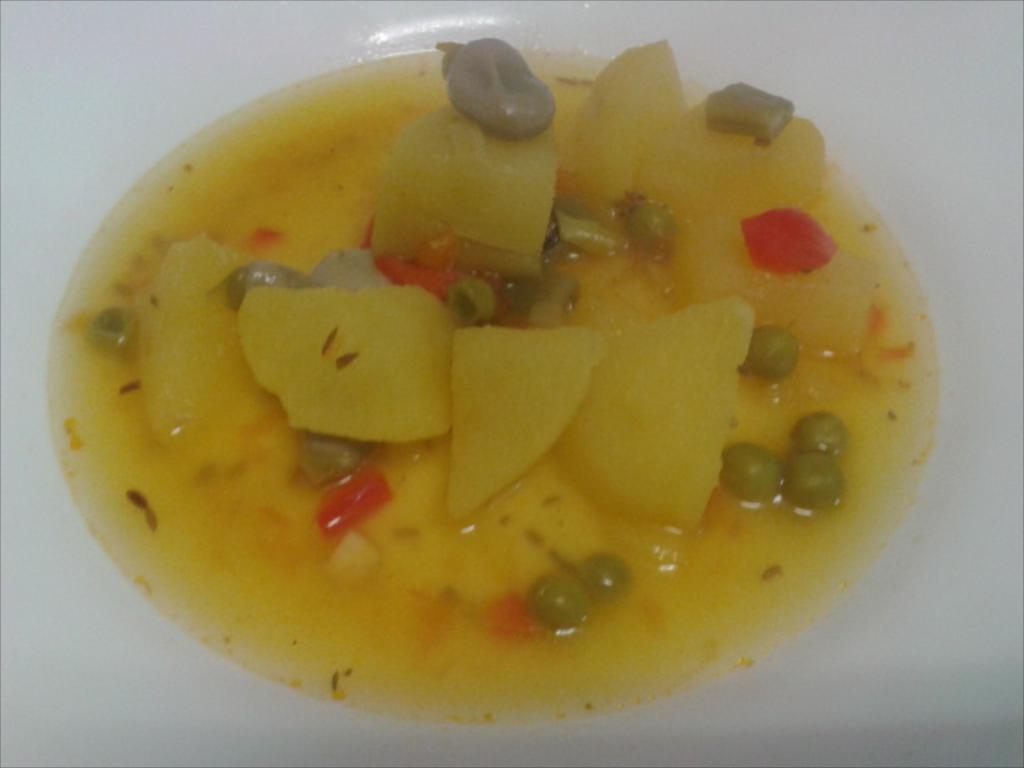Can you describe this image briefly? In this image we can see food item on the white colored surface. 